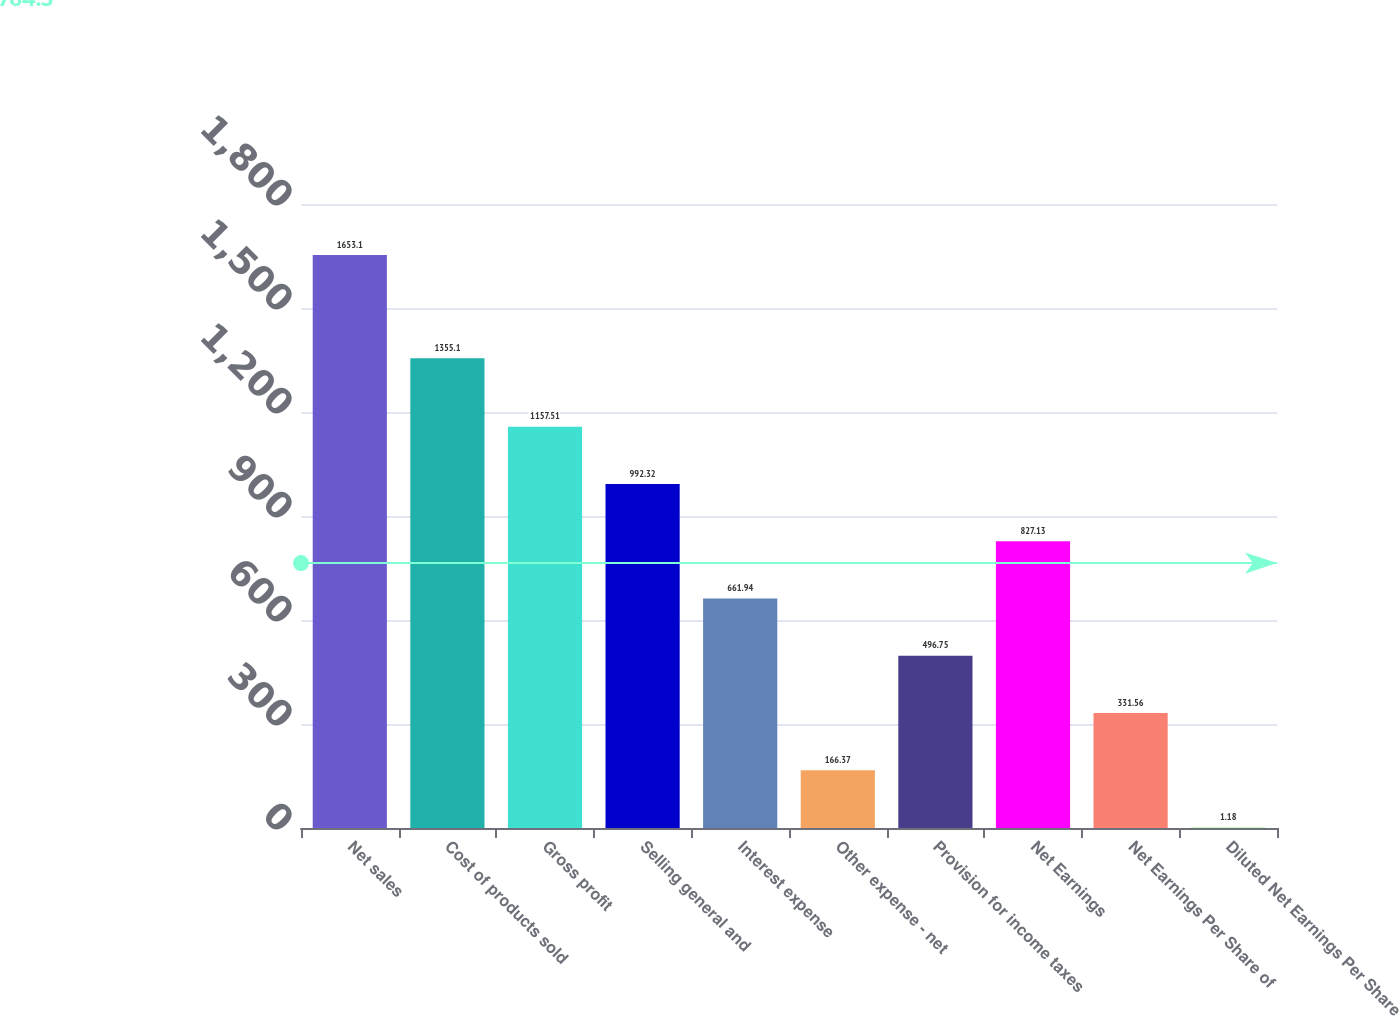Convert chart to OTSL. <chart><loc_0><loc_0><loc_500><loc_500><bar_chart><fcel>Net sales<fcel>Cost of products sold<fcel>Gross profit<fcel>Selling general and<fcel>Interest expense<fcel>Other expense - net<fcel>Provision for income taxes<fcel>Net Earnings<fcel>Net Earnings Per Share of<fcel>Diluted Net Earnings Per Share<nl><fcel>1653.1<fcel>1355.1<fcel>1157.51<fcel>992.32<fcel>661.94<fcel>166.37<fcel>496.75<fcel>827.13<fcel>331.56<fcel>1.18<nl></chart> 